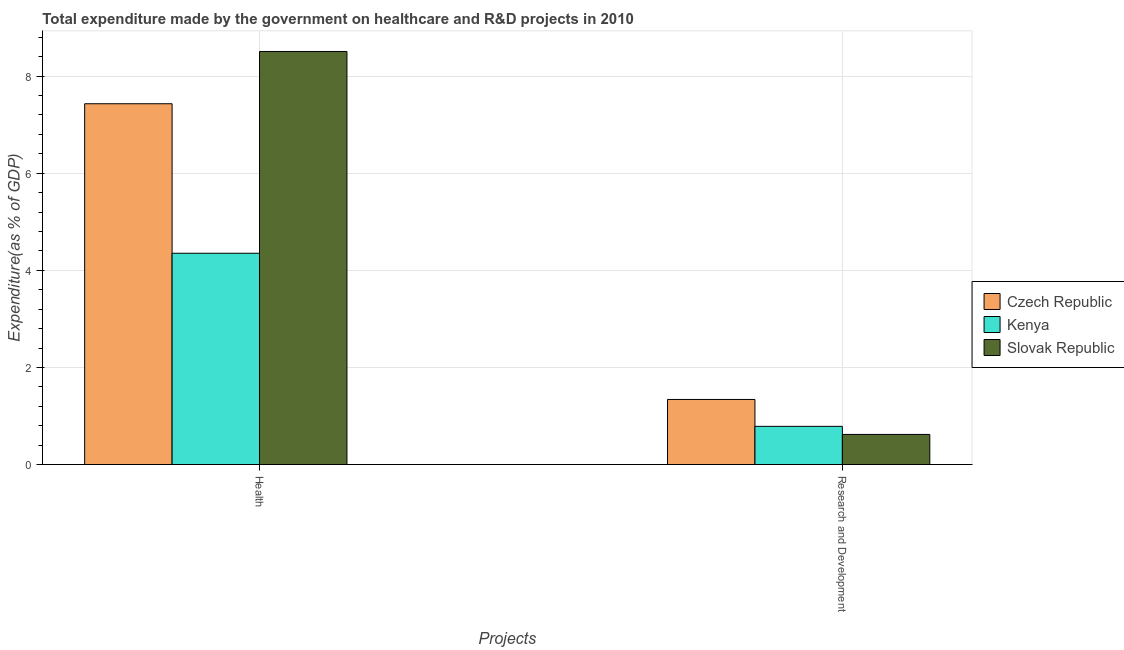Are the number of bars on each tick of the X-axis equal?
Keep it short and to the point. Yes. How many bars are there on the 1st tick from the left?
Give a very brief answer. 3. What is the label of the 2nd group of bars from the left?
Provide a short and direct response. Research and Development. What is the expenditure in healthcare in Kenya?
Make the answer very short. 4.35. Across all countries, what is the maximum expenditure in healthcare?
Keep it short and to the point. 8.51. Across all countries, what is the minimum expenditure in r&d?
Ensure brevity in your answer.  0.62. In which country was the expenditure in healthcare maximum?
Provide a succinct answer. Slovak Republic. In which country was the expenditure in r&d minimum?
Your response must be concise. Slovak Republic. What is the total expenditure in r&d in the graph?
Your response must be concise. 2.75. What is the difference between the expenditure in healthcare in Slovak Republic and that in Kenya?
Ensure brevity in your answer.  4.16. What is the difference between the expenditure in healthcare in Czech Republic and the expenditure in r&d in Slovak Republic?
Ensure brevity in your answer.  6.81. What is the average expenditure in healthcare per country?
Provide a short and direct response. 6.76. What is the difference between the expenditure in r&d and expenditure in healthcare in Kenya?
Provide a short and direct response. -3.57. In how many countries, is the expenditure in r&d greater than 1.2000000000000002 %?
Your answer should be compact. 1. What is the ratio of the expenditure in healthcare in Slovak Republic to that in Kenya?
Give a very brief answer. 1.96. Is the expenditure in r&d in Slovak Republic less than that in Czech Republic?
Offer a very short reply. Yes. In how many countries, is the expenditure in healthcare greater than the average expenditure in healthcare taken over all countries?
Offer a very short reply. 2. What does the 2nd bar from the left in Research and Development represents?
Ensure brevity in your answer.  Kenya. What does the 2nd bar from the right in Research and Development represents?
Offer a very short reply. Kenya. How many bars are there?
Provide a succinct answer. 6. Are all the bars in the graph horizontal?
Ensure brevity in your answer.  No. How many countries are there in the graph?
Offer a terse response. 3. What is the difference between two consecutive major ticks on the Y-axis?
Give a very brief answer. 2. Are the values on the major ticks of Y-axis written in scientific E-notation?
Keep it short and to the point. No. Does the graph contain any zero values?
Provide a succinct answer. No. Does the graph contain grids?
Offer a terse response. Yes. Where does the legend appear in the graph?
Your response must be concise. Center right. How are the legend labels stacked?
Give a very brief answer. Vertical. What is the title of the graph?
Your response must be concise. Total expenditure made by the government on healthcare and R&D projects in 2010. Does "Curacao" appear as one of the legend labels in the graph?
Make the answer very short. No. What is the label or title of the X-axis?
Your answer should be compact. Projects. What is the label or title of the Y-axis?
Give a very brief answer. Expenditure(as % of GDP). What is the Expenditure(as % of GDP) of Czech Republic in Health?
Keep it short and to the point. 7.43. What is the Expenditure(as % of GDP) in Kenya in Health?
Provide a succinct answer. 4.35. What is the Expenditure(as % of GDP) in Slovak Republic in Health?
Your response must be concise. 8.51. What is the Expenditure(as % of GDP) in Czech Republic in Research and Development?
Your answer should be very brief. 1.34. What is the Expenditure(as % of GDP) in Kenya in Research and Development?
Make the answer very short. 0.79. What is the Expenditure(as % of GDP) in Slovak Republic in Research and Development?
Keep it short and to the point. 0.62. Across all Projects, what is the maximum Expenditure(as % of GDP) of Czech Republic?
Your answer should be compact. 7.43. Across all Projects, what is the maximum Expenditure(as % of GDP) of Kenya?
Give a very brief answer. 4.35. Across all Projects, what is the maximum Expenditure(as % of GDP) in Slovak Republic?
Your response must be concise. 8.51. Across all Projects, what is the minimum Expenditure(as % of GDP) of Czech Republic?
Your response must be concise. 1.34. Across all Projects, what is the minimum Expenditure(as % of GDP) in Kenya?
Give a very brief answer. 0.79. Across all Projects, what is the minimum Expenditure(as % of GDP) in Slovak Republic?
Provide a succinct answer. 0.62. What is the total Expenditure(as % of GDP) of Czech Republic in the graph?
Offer a terse response. 8.77. What is the total Expenditure(as % of GDP) of Kenya in the graph?
Make the answer very short. 5.14. What is the total Expenditure(as % of GDP) of Slovak Republic in the graph?
Offer a terse response. 9.13. What is the difference between the Expenditure(as % of GDP) in Czech Republic in Health and that in Research and Development?
Ensure brevity in your answer.  6.09. What is the difference between the Expenditure(as % of GDP) of Kenya in Health and that in Research and Development?
Give a very brief answer. 3.57. What is the difference between the Expenditure(as % of GDP) in Slovak Republic in Health and that in Research and Development?
Ensure brevity in your answer.  7.89. What is the difference between the Expenditure(as % of GDP) in Czech Republic in Health and the Expenditure(as % of GDP) in Kenya in Research and Development?
Offer a very short reply. 6.65. What is the difference between the Expenditure(as % of GDP) of Czech Republic in Health and the Expenditure(as % of GDP) of Slovak Republic in Research and Development?
Provide a short and direct response. 6.81. What is the difference between the Expenditure(as % of GDP) in Kenya in Health and the Expenditure(as % of GDP) in Slovak Republic in Research and Development?
Your response must be concise. 3.73. What is the average Expenditure(as % of GDP) in Czech Republic per Projects?
Make the answer very short. 4.39. What is the average Expenditure(as % of GDP) of Kenya per Projects?
Your response must be concise. 2.57. What is the average Expenditure(as % of GDP) in Slovak Republic per Projects?
Make the answer very short. 4.56. What is the difference between the Expenditure(as % of GDP) of Czech Republic and Expenditure(as % of GDP) of Kenya in Health?
Your answer should be very brief. 3.08. What is the difference between the Expenditure(as % of GDP) of Czech Republic and Expenditure(as % of GDP) of Slovak Republic in Health?
Give a very brief answer. -1.08. What is the difference between the Expenditure(as % of GDP) in Kenya and Expenditure(as % of GDP) in Slovak Republic in Health?
Provide a succinct answer. -4.16. What is the difference between the Expenditure(as % of GDP) in Czech Republic and Expenditure(as % of GDP) in Kenya in Research and Development?
Ensure brevity in your answer.  0.55. What is the difference between the Expenditure(as % of GDP) in Czech Republic and Expenditure(as % of GDP) in Slovak Republic in Research and Development?
Your answer should be very brief. 0.72. What is the difference between the Expenditure(as % of GDP) of Kenya and Expenditure(as % of GDP) of Slovak Republic in Research and Development?
Provide a succinct answer. 0.17. What is the ratio of the Expenditure(as % of GDP) of Czech Republic in Health to that in Research and Development?
Make the answer very short. 5.55. What is the ratio of the Expenditure(as % of GDP) in Kenya in Health to that in Research and Development?
Keep it short and to the point. 5.54. What is the ratio of the Expenditure(as % of GDP) in Slovak Republic in Health to that in Research and Development?
Your answer should be very brief. 13.73. What is the difference between the highest and the second highest Expenditure(as % of GDP) of Czech Republic?
Your answer should be very brief. 6.09. What is the difference between the highest and the second highest Expenditure(as % of GDP) of Kenya?
Make the answer very short. 3.57. What is the difference between the highest and the second highest Expenditure(as % of GDP) in Slovak Republic?
Provide a short and direct response. 7.89. What is the difference between the highest and the lowest Expenditure(as % of GDP) in Czech Republic?
Keep it short and to the point. 6.09. What is the difference between the highest and the lowest Expenditure(as % of GDP) of Kenya?
Your response must be concise. 3.57. What is the difference between the highest and the lowest Expenditure(as % of GDP) in Slovak Republic?
Keep it short and to the point. 7.89. 